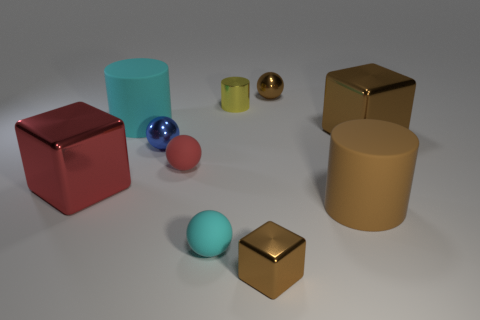Can you describe the settings or possible uses for these objects? The objects depicted appear to be simplistic 3D models often used in visual arts for practicing rendering techniques. In a practical setting, they could represent a variety of real-world items like containers, balls, or toys and may be used for educational purposes or to demonstrate material properties in various lighting conditions. 